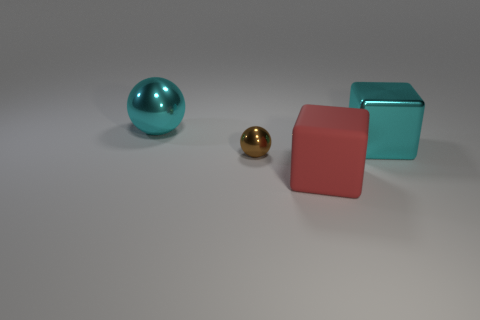Add 2 matte objects. How many objects exist? 6 Add 2 yellow metallic cylinders. How many yellow metallic cylinders exist? 2 Subtract 1 red blocks. How many objects are left? 3 Subtract all small gray metal blocks. Subtract all spheres. How many objects are left? 2 Add 3 metal objects. How many metal objects are left? 6 